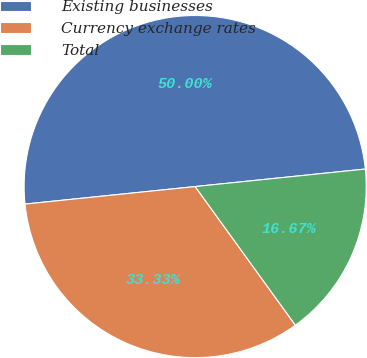Convert chart to OTSL. <chart><loc_0><loc_0><loc_500><loc_500><pie_chart><fcel>Existing businesses<fcel>Currency exchange rates<fcel>Total<nl><fcel>50.0%<fcel>33.33%<fcel>16.67%<nl></chart> 